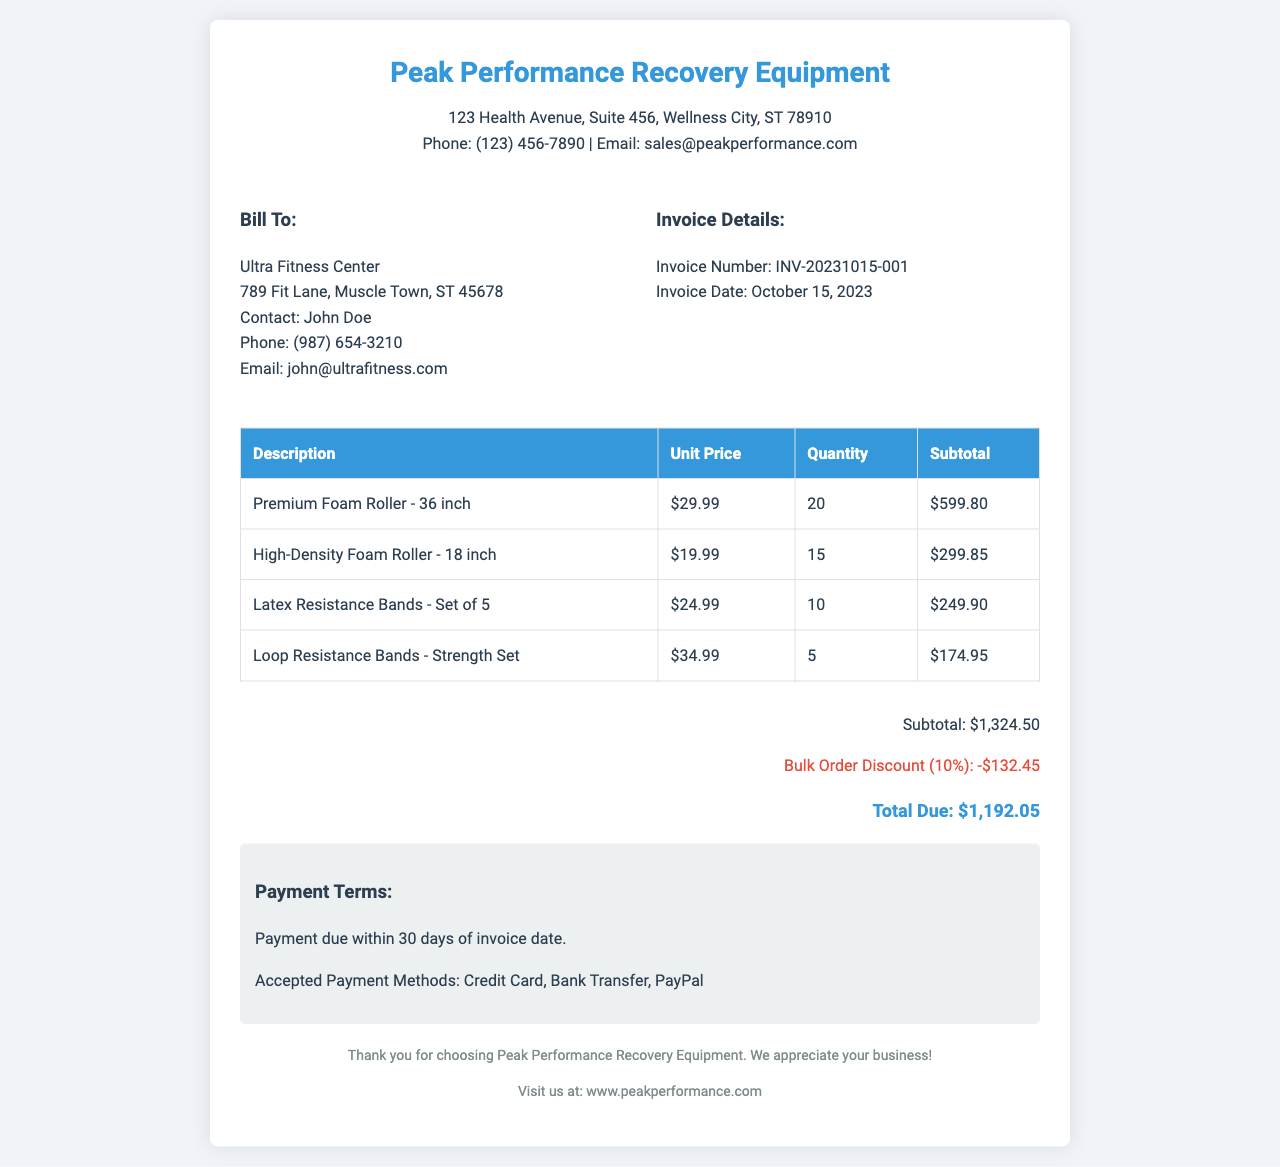What is the company name? The company name is listed prominently at the top of the document.
Answer: Peak Performance Recovery Equipment What is the invoice number? The invoice number is provided in the invoice details section.
Answer: INV-20231015-001 What is the date of the invoice? The invoice date is explicitly mentioned in the invoice details section.
Answer: October 15, 2023 What is the quantity of Premium Foam Rollers ordered? The quantity is specified in the table listing the items.
Answer: 20 What is the subtotal before discount? The subtotal is clearly stated in the totals section of the invoice.
Answer: $1,324.50 What percentage is the bulk order discount? The discount percentage is mentioned alongside the discount details.
Answer: 10% Who is the contact person for Ultra Fitness Center? The contact person's name is provided under the bill to section.
Answer: John Doe What payment terms are indicated in the document? The payment terms are outlined in a designated section towards the end of the document.
Answer: Payment due within 30 days of invoice date What accepted payment methods are listed? The accepted payment methods are detailed in the payment terms section.
Answer: Credit Card, Bank Transfer, PayPal 